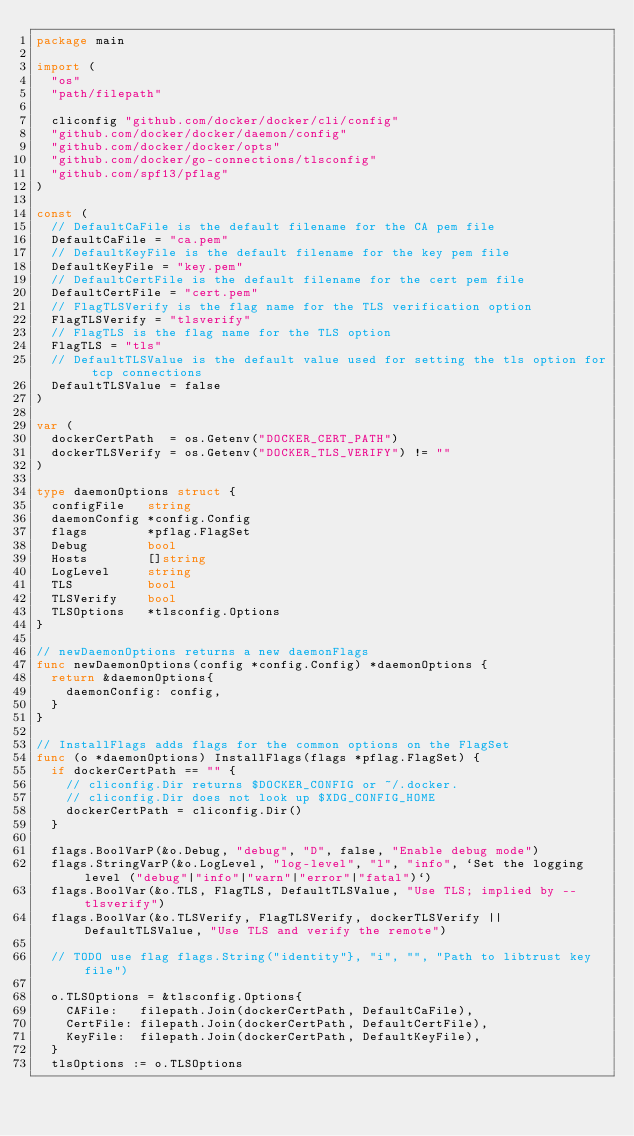<code> <loc_0><loc_0><loc_500><loc_500><_Go_>package main

import (
	"os"
	"path/filepath"

	cliconfig "github.com/docker/docker/cli/config"
	"github.com/docker/docker/daemon/config"
	"github.com/docker/docker/opts"
	"github.com/docker/go-connections/tlsconfig"
	"github.com/spf13/pflag"
)

const (
	// DefaultCaFile is the default filename for the CA pem file
	DefaultCaFile = "ca.pem"
	// DefaultKeyFile is the default filename for the key pem file
	DefaultKeyFile = "key.pem"
	// DefaultCertFile is the default filename for the cert pem file
	DefaultCertFile = "cert.pem"
	// FlagTLSVerify is the flag name for the TLS verification option
	FlagTLSVerify = "tlsverify"
	// FlagTLS is the flag name for the TLS option
	FlagTLS = "tls"
	// DefaultTLSValue is the default value used for setting the tls option for tcp connections
	DefaultTLSValue = false
)

var (
	dockerCertPath  = os.Getenv("DOCKER_CERT_PATH")
	dockerTLSVerify = os.Getenv("DOCKER_TLS_VERIFY") != ""
)

type daemonOptions struct {
	configFile   string
	daemonConfig *config.Config
	flags        *pflag.FlagSet
	Debug        bool
	Hosts        []string
	LogLevel     string
	TLS          bool
	TLSVerify    bool
	TLSOptions   *tlsconfig.Options
}

// newDaemonOptions returns a new daemonFlags
func newDaemonOptions(config *config.Config) *daemonOptions {
	return &daemonOptions{
		daemonConfig: config,
	}
}

// InstallFlags adds flags for the common options on the FlagSet
func (o *daemonOptions) InstallFlags(flags *pflag.FlagSet) {
	if dockerCertPath == "" {
		// cliconfig.Dir returns $DOCKER_CONFIG or ~/.docker.
		// cliconfig.Dir does not look up $XDG_CONFIG_HOME
		dockerCertPath = cliconfig.Dir()
	}

	flags.BoolVarP(&o.Debug, "debug", "D", false, "Enable debug mode")
	flags.StringVarP(&o.LogLevel, "log-level", "l", "info", `Set the logging level ("debug"|"info"|"warn"|"error"|"fatal")`)
	flags.BoolVar(&o.TLS, FlagTLS, DefaultTLSValue, "Use TLS; implied by --tlsverify")
	flags.BoolVar(&o.TLSVerify, FlagTLSVerify, dockerTLSVerify || DefaultTLSValue, "Use TLS and verify the remote")

	// TODO use flag flags.String("identity"}, "i", "", "Path to libtrust key file")

	o.TLSOptions = &tlsconfig.Options{
		CAFile:   filepath.Join(dockerCertPath, DefaultCaFile),
		CertFile: filepath.Join(dockerCertPath, DefaultCertFile),
		KeyFile:  filepath.Join(dockerCertPath, DefaultKeyFile),
	}
	tlsOptions := o.TLSOptions</code> 